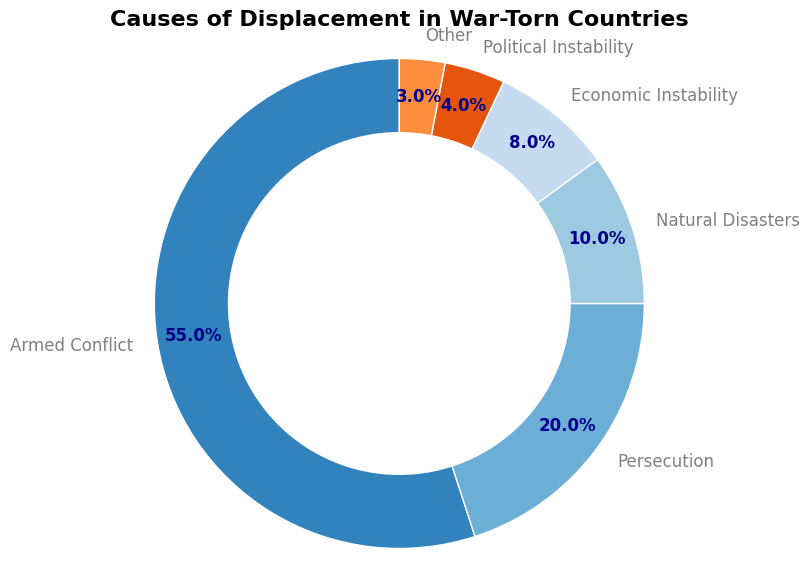Which cause is responsible for the highest percentage of displacement? The chart shows multiple categories with associated percentages. The highest percentage is linked to "Armed Conflict" at 55%.
Answer: Armed Conflict What percentage of displacement is due to Persecution and Natural Disasters combined? The chart lists Persecution as 20% and Natural Disasters as 10%. Summing these percentages gives 20% + 10% = 30%.
Answer: 30% Which causes of displacement have percentages less than 10%? Observing the pie chart, the causes with percentages less than 10% are Natural Disasters (10%), Economic Instability (8%), Political Instability (4%), and Other (3%).
Answer: Natural Disasters, Economic Instability, Political Instability, Other Is the percentage caused by Armed Conflict greater than the sum of Economic and Political Instability? Armed Conflict is 55%. Economic Instability is 8% and Political Instability is 4%. Summing these gives 8% + 4% = 12%, which is much less than 55%.
Answer: Yes What is the difference in percentage between Armed Conflict and Persecution? Armed Conflict has 55% and Persecution has 20%. The difference is 55% - 20% = 35%.
Answer: 35 Which category other than Armed Conflict has the highest displacement percentage? Excluding Armed Conflict which is 55%, the next highest percentage is Persecution with 20%.
Answer: Persecution What fraction of the total displacement is caused by Political and Economic Instability together? Political Instability is 4% and Economic Instability is 8%. These together add up to 4% + 8% = 12%.
Answer: 12% Is the percentage for Natural Disasters greater than the percentage for Persecution? The pie chart shows Natural Disasters at 10% and Persecution at 20%. 10% is less than 20%.
Answer: No 